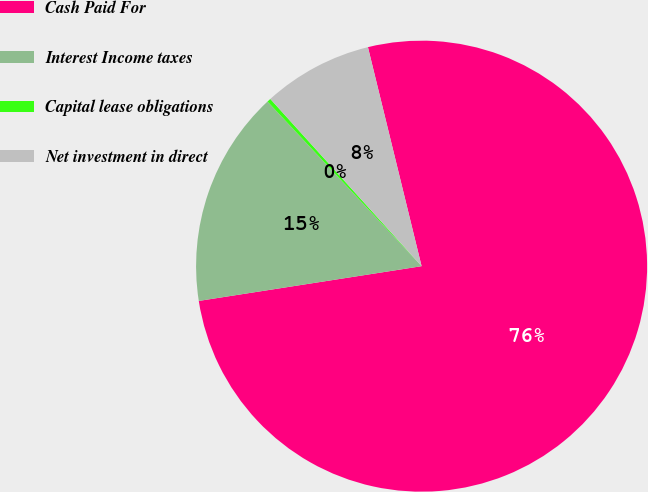Convert chart to OTSL. <chart><loc_0><loc_0><loc_500><loc_500><pie_chart><fcel>Cash Paid For<fcel>Interest Income taxes<fcel>Capital lease obligations<fcel>Net investment in direct<nl><fcel>76.37%<fcel>15.49%<fcel>0.27%<fcel>7.88%<nl></chart> 